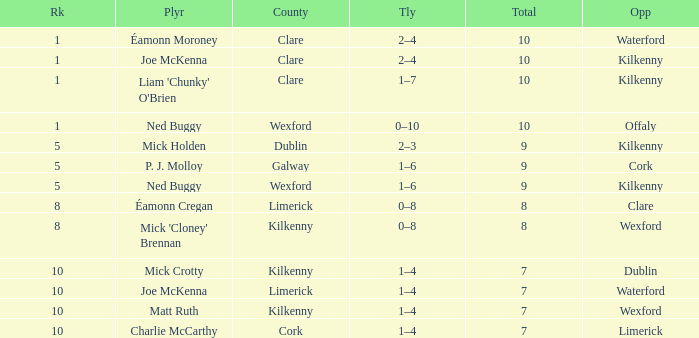What is galway county's total? 9.0. 